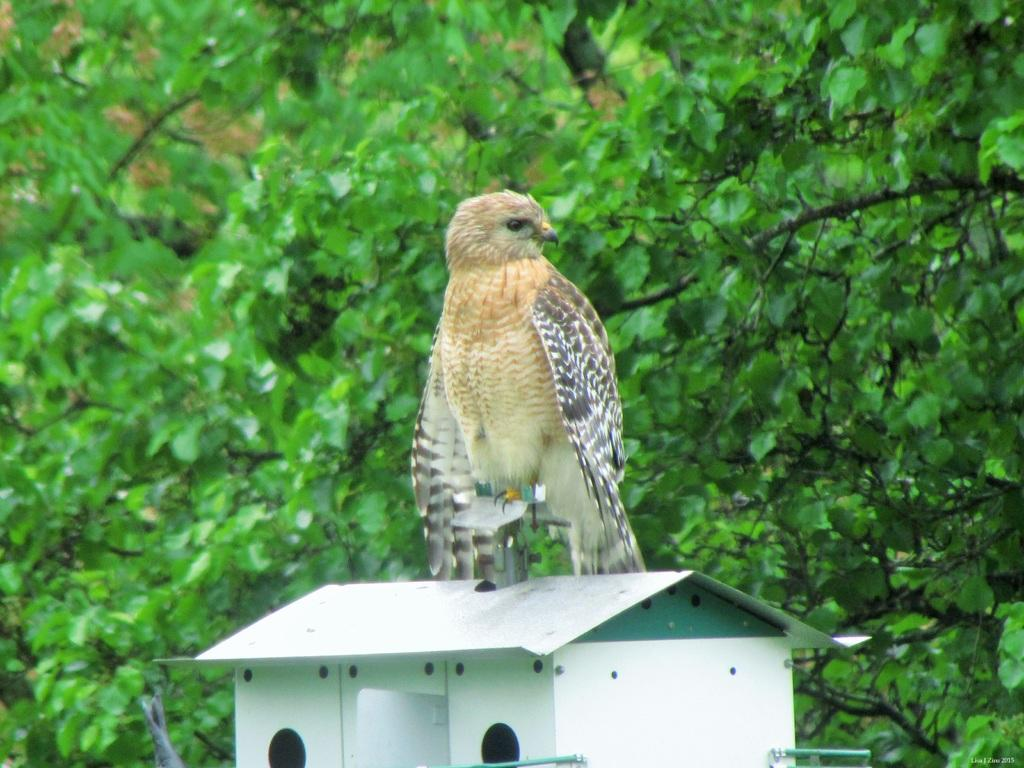What type of animal can be seen in the image? There is a bird in the image. Where is the bird located? The bird is on a birdhouse. What type of vegetation is present in the image? There are trees in the image. What is the color of the trees? The trees are green. What colors can be seen on the bird? The bird has brown, white, and black colors. What type of bait is the bird using to catch fish in the image? There is no indication in the image that the bird is trying to catch fish, nor is there any bait present. 